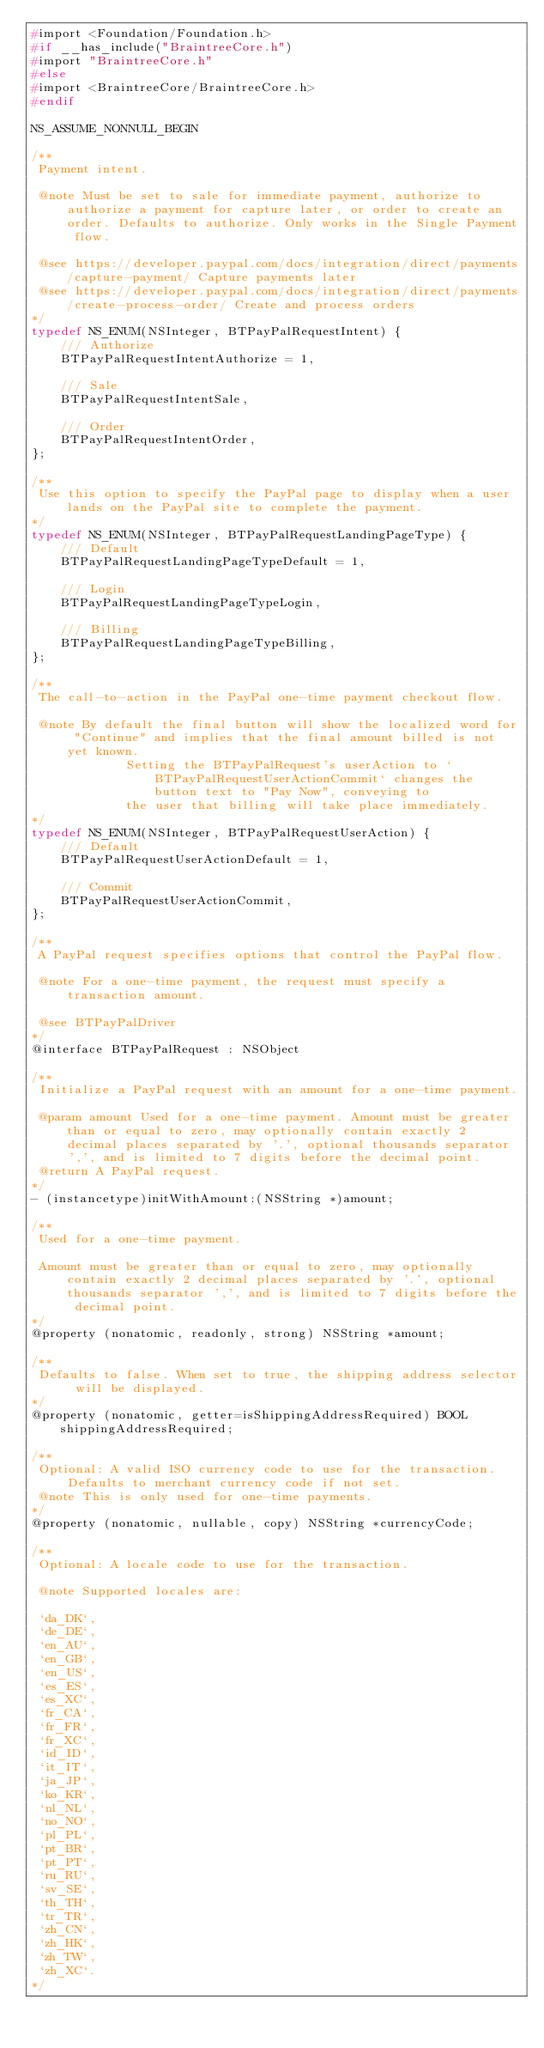Convert code to text. <code><loc_0><loc_0><loc_500><loc_500><_C_>#import <Foundation/Foundation.h>
#if __has_include("BraintreeCore.h")
#import "BraintreeCore.h"
#else
#import <BraintreeCore/BraintreeCore.h>
#endif

NS_ASSUME_NONNULL_BEGIN

/**
 Payment intent.

 @note Must be set to sale for immediate payment, authorize to authorize a payment for capture later, or order to create an order. Defaults to authorize. Only works in the Single Payment flow.

 @see https://developer.paypal.com/docs/integration/direct/payments/capture-payment/ Capture payments later
 @see https://developer.paypal.com/docs/integration/direct/payments/create-process-order/ Create and process orders
*/
typedef NS_ENUM(NSInteger, BTPayPalRequestIntent) {
    /// Authorize
    BTPayPalRequestIntentAuthorize = 1,

    /// Sale
    BTPayPalRequestIntentSale,

    /// Order
    BTPayPalRequestIntentOrder,
};

/**
 Use this option to specify the PayPal page to display when a user lands on the PayPal site to complete the payment.
*/
typedef NS_ENUM(NSInteger, BTPayPalRequestLandingPageType) {
    /// Default
    BTPayPalRequestLandingPageTypeDefault = 1,

    /// Login
    BTPayPalRequestLandingPageTypeLogin,

    /// Billing
    BTPayPalRequestLandingPageTypeBilling,
};

/**
 The call-to-action in the PayPal one-time payment checkout flow.

 @note By default the final button will show the localized word for "Continue" and implies that the final amount billed is not yet known.
             Setting the BTPayPalRequest's userAction to `BTPayPalRequestUserActionCommit` changes the button text to "Pay Now", conveying to
             the user that billing will take place immediately.
*/
typedef NS_ENUM(NSInteger, BTPayPalRequestUserAction) {
    /// Default
    BTPayPalRequestUserActionDefault = 1,

    /// Commit
    BTPayPalRequestUserActionCommit,
};

/**
 A PayPal request specifies options that control the PayPal flow.

 @note For a one-time payment, the request must specify a transaction amount.

 @see BTPayPalDriver
*/
@interface BTPayPalRequest : NSObject

/**
 Initialize a PayPal request with an amount for a one-time payment.

 @param amount Used for a one-time payment. Amount must be greater than or equal to zero, may optionally contain exactly 2 decimal places separated by '.', optional thousands separator ',', and is limited to 7 digits before the decimal point.
 @return A PayPal request.
*/
- (instancetype)initWithAmount:(NSString *)amount;

/**
 Used for a one-time payment.

 Amount must be greater than or equal to zero, may optionally contain exactly 2 decimal places separated by '.', optional thousands separator ',', and is limited to 7 digits before the decimal point.
*/
@property (nonatomic, readonly, strong) NSString *amount;

/**
 Defaults to false. When set to true, the shipping address selector will be displayed.
*/
@property (nonatomic, getter=isShippingAddressRequired) BOOL shippingAddressRequired;

/**
 Optional: A valid ISO currency code to use for the transaction. Defaults to merchant currency code if not set.
 @note This is only used for one-time payments.
*/
@property (nonatomic, nullable, copy) NSString *currencyCode;

/**
 Optional: A locale code to use for the transaction.

 @note Supported locales are:

 `da_DK`,
 `de_DE`,
 `en_AU`,
 `en_GB`,
 `en_US`,
 `es_ES`,
 `es_XC`,
 `fr_CA`,
 `fr_FR`,
 `fr_XC`,
 `id_ID`,
 `it_IT`,
 `ja_JP`,
 `ko_KR`,
 `nl_NL`,
 `no_NO`,
 `pl_PL`,
 `pt_BR`,
 `pt_PT`,
 `ru_RU`,
 `sv_SE`,
 `th_TH`,
 `tr_TR`,
 `zh_CN`,
 `zh_HK`,
 `zh_TW`,
 `zh_XC`.
*/</code> 